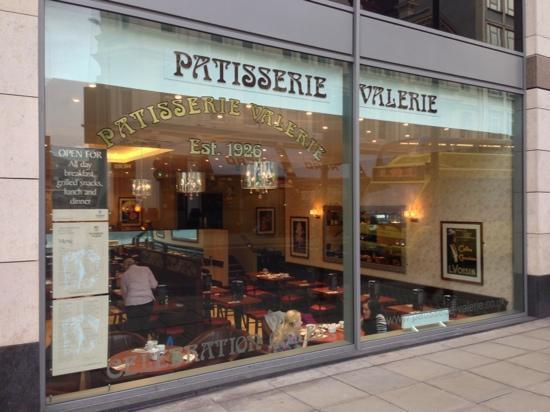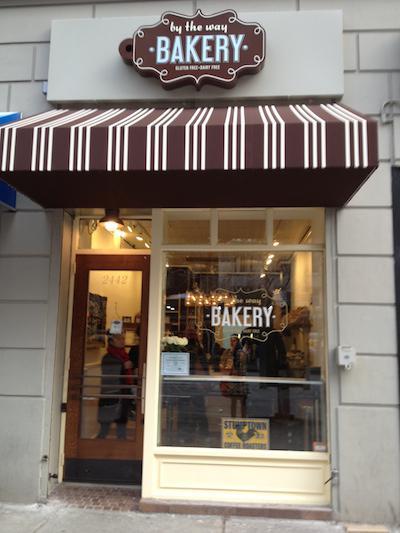The first image is the image on the left, the second image is the image on the right. Evaluate the accuracy of this statement regarding the images: "There are tables and chairs for the customers.". Is it true? Answer yes or no. Yes. The first image is the image on the left, the second image is the image on the right. Examine the images to the left and right. Is the description "An image contains a view of a storefront from an outside perspective." accurate? Answer yes or no. Yes. 